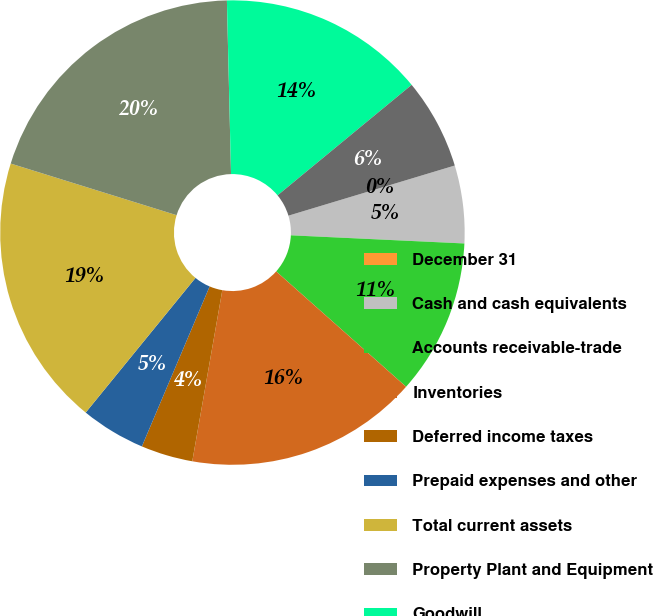Convert chart to OTSL. <chart><loc_0><loc_0><loc_500><loc_500><pie_chart><fcel>December 31<fcel>Cash and cash equivalents<fcel>Accounts receivable-trade<fcel>Inventories<fcel>Deferred income taxes<fcel>Prepaid expenses and other<fcel>Total current assets<fcel>Property Plant and Equipment<fcel>Goodwill<fcel>Other Intangibles<nl><fcel>0.0%<fcel>5.41%<fcel>10.81%<fcel>16.21%<fcel>3.61%<fcel>4.51%<fcel>18.92%<fcel>19.82%<fcel>14.41%<fcel>6.31%<nl></chart> 